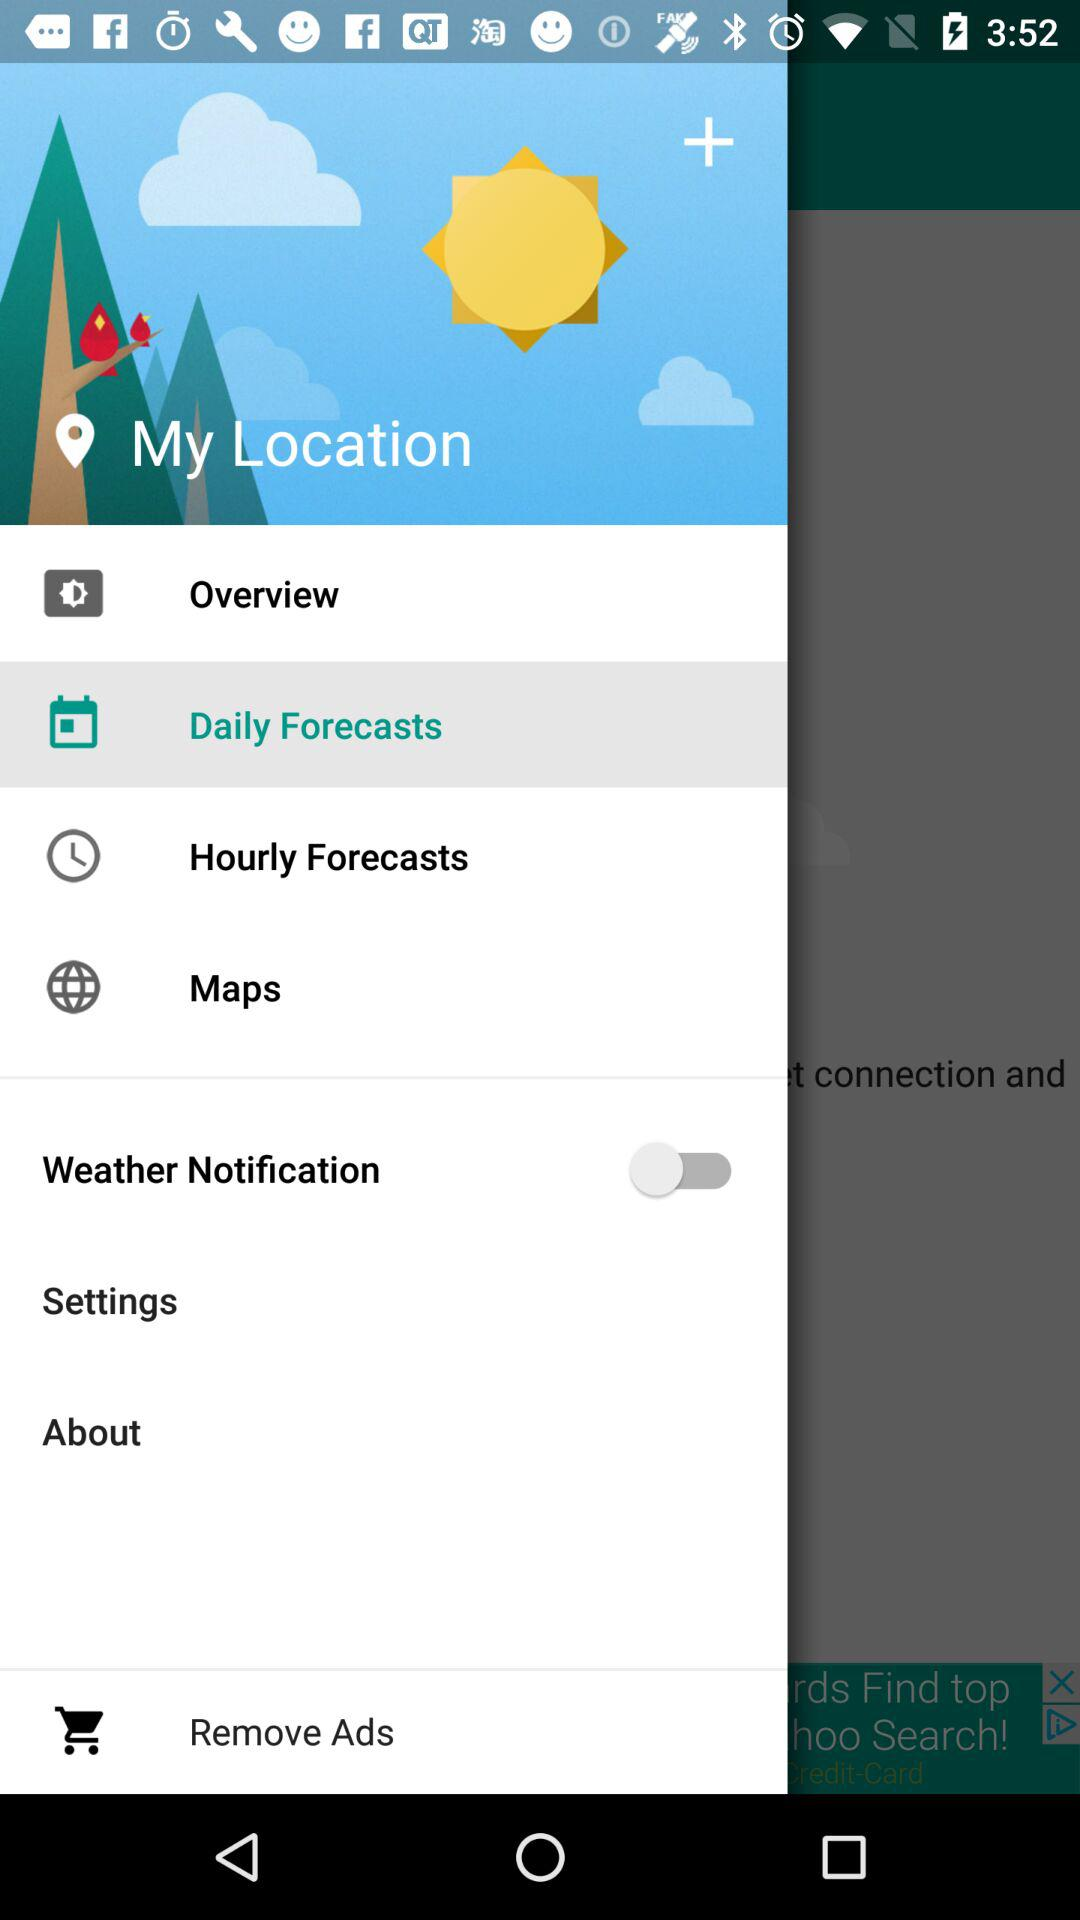What is the status of "Weather Notification"? The status is "off". 